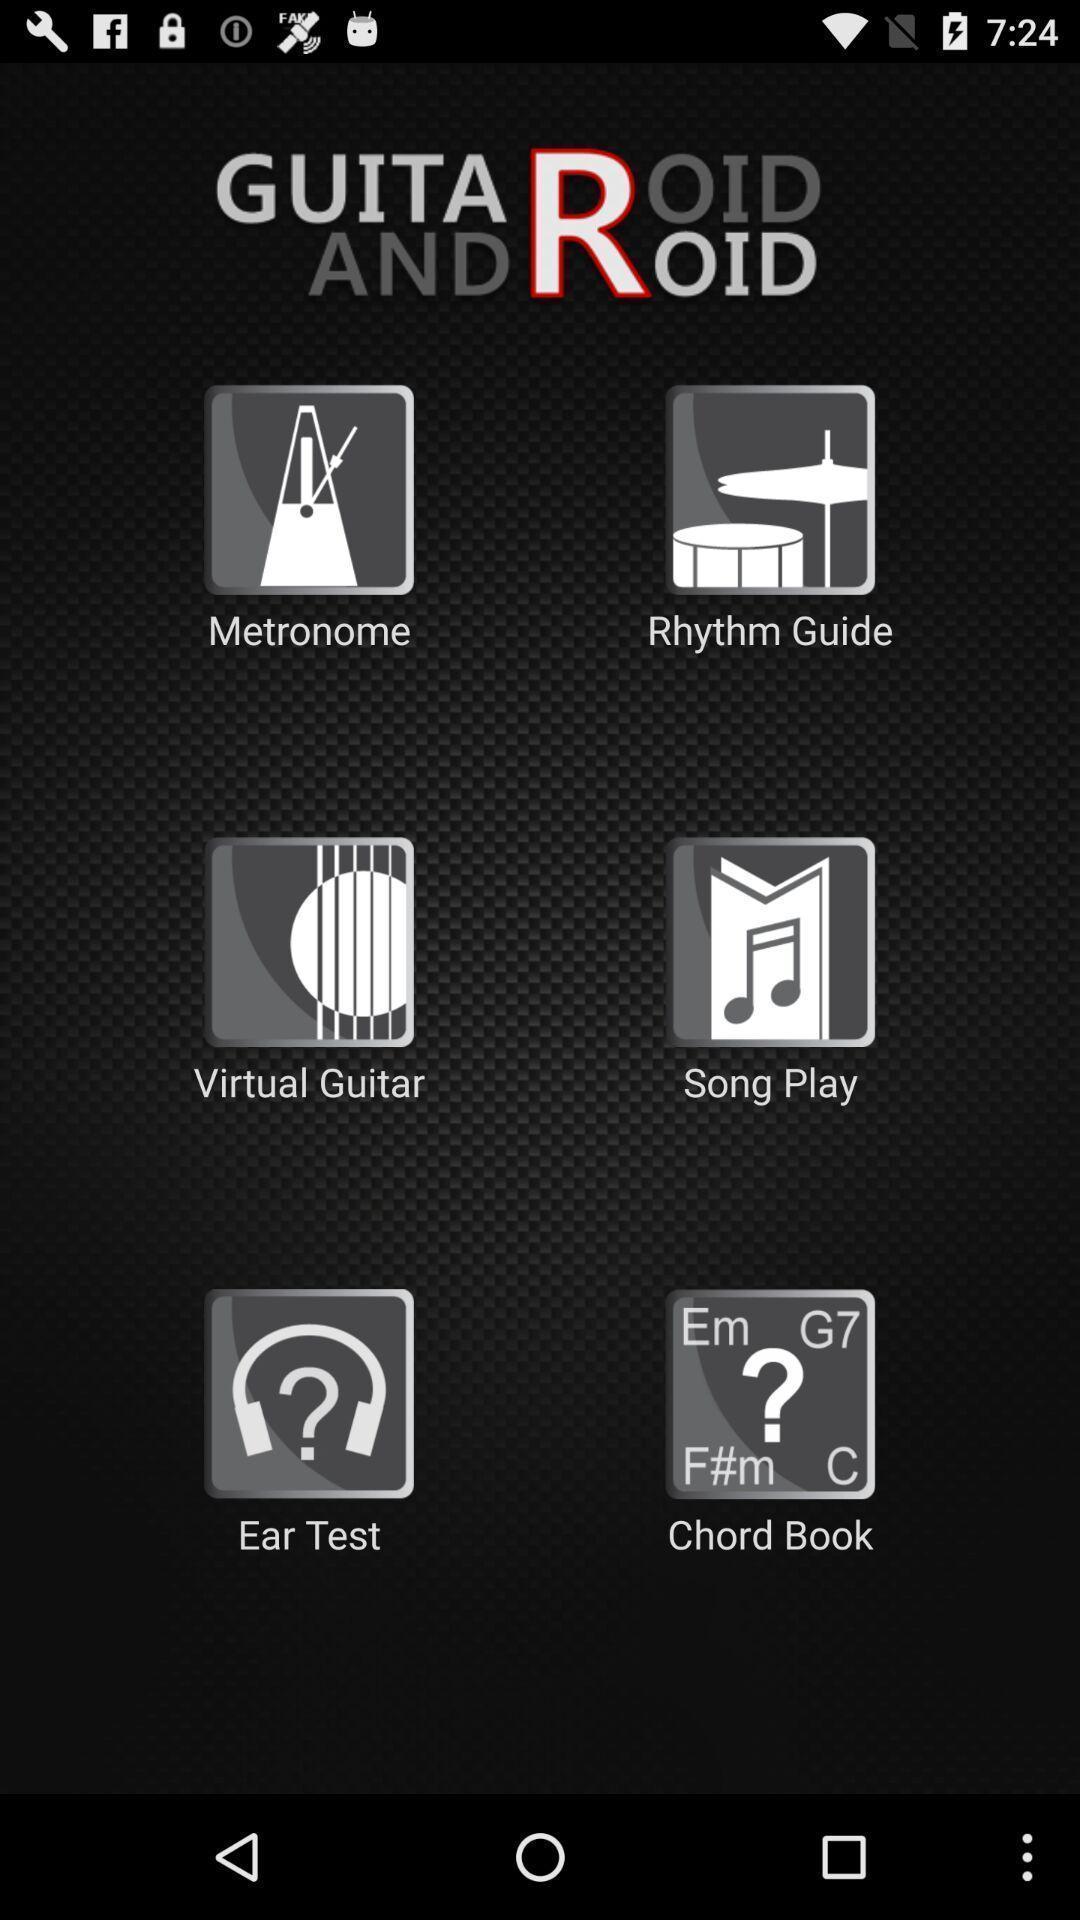What can you discern from this picture? Welcome page of a music app. 